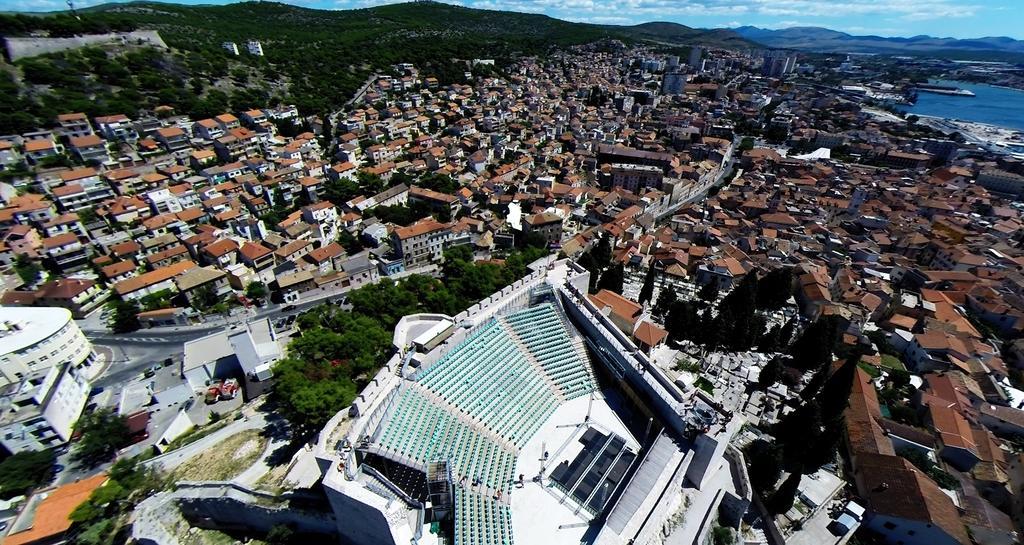How would you summarize this image in a sentence or two? This is an aerial view where we can see city with buildings, trees, and roads. In the background, we can see mountains, sky, cloud, and the water. 